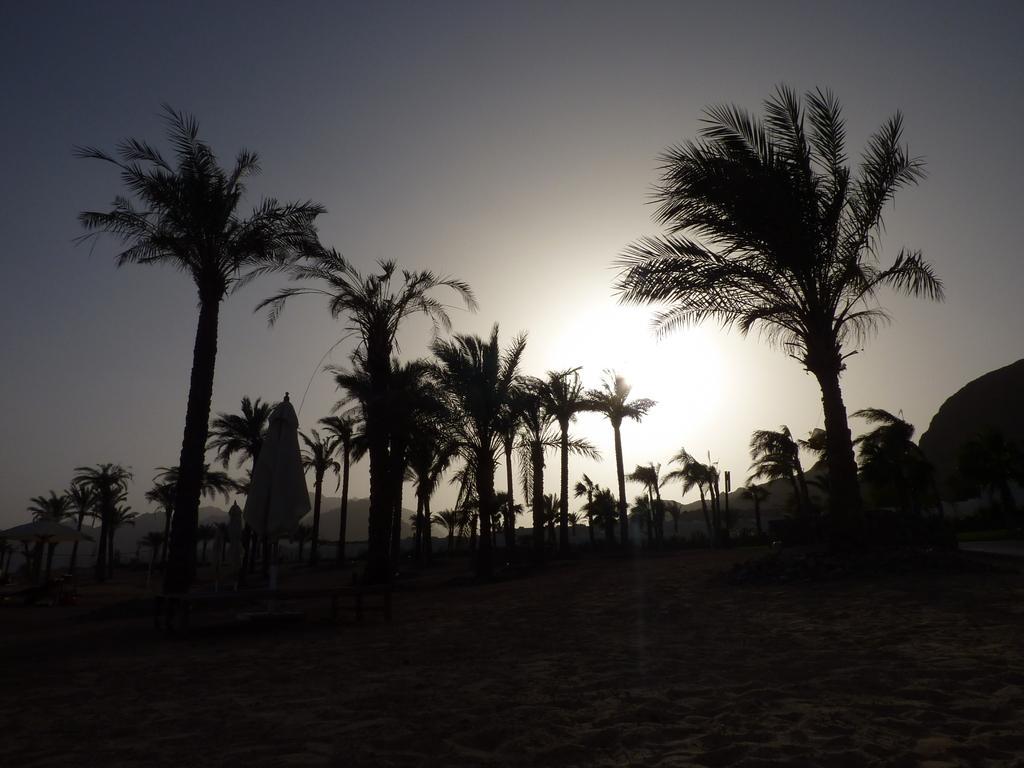Describe this image in one or two sentences. In this image I can see number of trees and in background I can see the sun and the sky. I can also see this image is little bit in dark. 